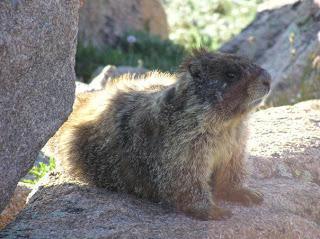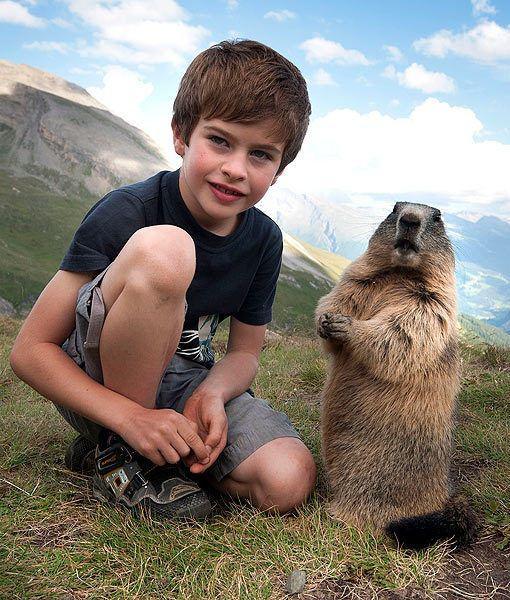The first image is the image on the left, the second image is the image on the right. For the images displayed, is the sentence "An image contains more than one rodent." factually correct? Answer yes or no. No. 